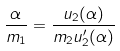Convert formula to latex. <formula><loc_0><loc_0><loc_500><loc_500>\frac { \alpha } { m _ { 1 } } = \frac { u _ { 2 } ( \alpha ) } { m _ { 2 } u _ { 2 } ^ { \prime } ( \alpha ) }</formula> 